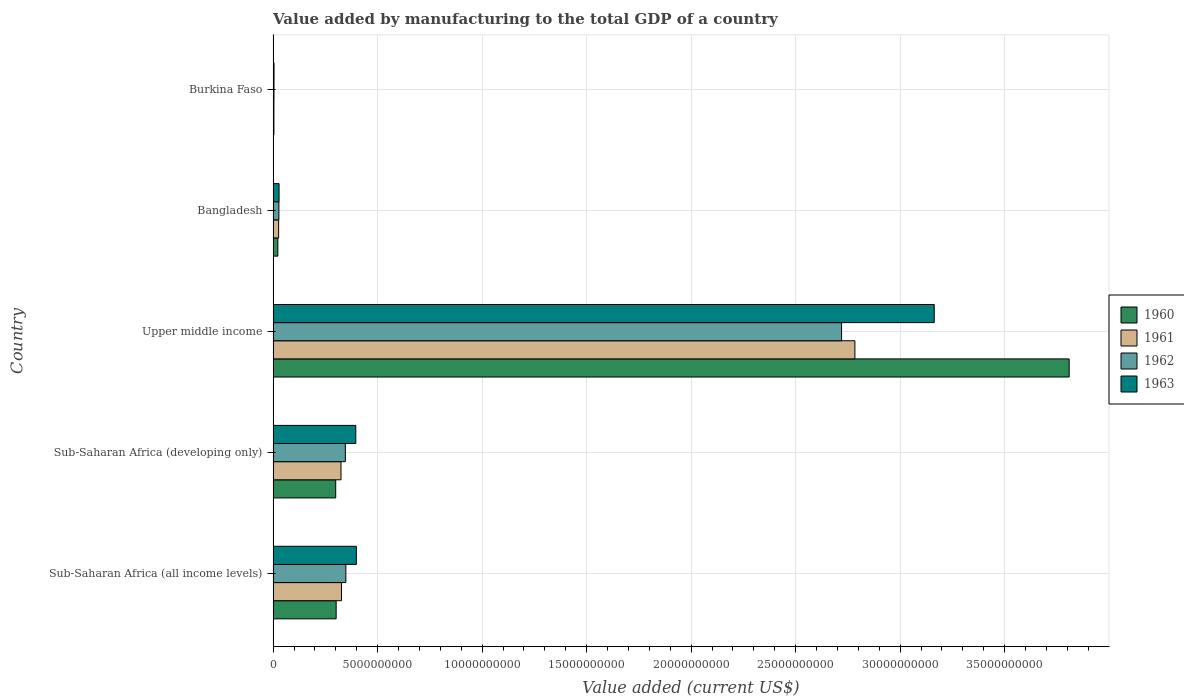How many groups of bars are there?
Give a very brief answer. 5. How many bars are there on the 4th tick from the top?
Offer a very short reply. 4. How many bars are there on the 5th tick from the bottom?
Offer a very short reply. 4. What is the label of the 1st group of bars from the top?
Offer a very short reply. Burkina Faso. In how many cases, is the number of bars for a given country not equal to the number of legend labels?
Make the answer very short. 0. What is the value added by manufacturing to the total GDP in 1960 in Upper middle income?
Your response must be concise. 3.81e+1. Across all countries, what is the maximum value added by manufacturing to the total GDP in 1960?
Your answer should be very brief. 3.81e+1. Across all countries, what is the minimum value added by manufacturing to the total GDP in 1960?
Your answer should be compact. 3.72e+07. In which country was the value added by manufacturing to the total GDP in 1962 maximum?
Your answer should be compact. Upper middle income. In which country was the value added by manufacturing to the total GDP in 1962 minimum?
Make the answer very short. Burkina Faso. What is the total value added by manufacturing to the total GDP in 1961 in the graph?
Ensure brevity in your answer.  3.47e+1. What is the difference between the value added by manufacturing to the total GDP in 1962 in Bangladesh and that in Upper middle income?
Provide a short and direct response. -2.69e+1. What is the difference between the value added by manufacturing to the total GDP in 1963 in Bangladesh and the value added by manufacturing to the total GDP in 1961 in Sub-Saharan Africa (developing only)?
Ensure brevity in your answer.  -2.96e+09. What is the average value added by manufacturing to the total GDP in 1963 per country?
Keep it short and to the point. 7.98e+09. What is the difference between the value added by manufacturing to the total GDP in 1962 and value added by manufacturing to the total GDP in 1960 in Burkina Faso?
Provide a succinct answer. 5.00e+06. What is the ratio of the value added by manufacturing to the total GDP in 1962 in Sub-Saharan Africa (all income levels) to that in Sub-Saharan Africa (developing only)?
Keep it short and to the point. 1.01. Is the value added by manufacturing to the total GDP in 1963 in Burkina Faso less than that in Sub-Saharan Africa (all income levels)?
Ensure brevity in your answer.  Yes. Is the difference between the value added by manufacturing to the total GDP in 1962 in Burkina Faso and Sub-Saharan Africa (developing only) greater than the difference between the value added by manufacturing to the total GDP in 1960 in Burkina Faso and Sub-Saharan Africa (developing only)?
Your response must be concise. No. What is the difference between the highest and the second highest value added by manufacturing to the total GDP in 1961?
Make the answer very short. 2.46e+1. What is the difference between the highest and the lowest value added by manufacturing to the total GDP in 1962?
Provide a succinct answer. 2.72e+1. What does the 4th bar from the bottom in Sub-Saharan Africa (developing only) represents?
Make the answer very short. 1963. What is the difference between two consecutive major ticks on the X-axis?
Ensure brevity in your answer.  5.00e+09. How many legend labels are there?
Your response must be concise. 4. What is the title of the graph?
Your answer should be compact. Value added by manufacturing to the total GDP of a country. What is the label or title of the X-axis?
Keep it short and to the point. Value added (current US$). What is the label or title of the Y-axis?
Ensure brevity in your answer.  Country. What is the Value added (current US$) of 1960 in Sub-Saharan Africa (all income levels)?
Your answer should be compact. 3.02e+09. What is the Value added (current US$) of 1961 in Sub-Saharan Africa (all income levels)?
Your answer should be very brief. 3.27e+09. What is the Value added (current US$) of 1962 in Sub-Saharan Africa (all income levels)?
Your answer should be very brief. 3.48e+09. What is the Value added (current US$) of 1963 in Sub-Saharan Africa (all income levels)?
Offer a very short reply. 3.98e+09. What is the Value added (current US$) in 1960 in Sub-Saharan Africa (developing only)?
Offer a terse response. 2.99e+09. What is the Value added (current US$) of 1961 in Sub-Saharan Africa (developing only)?
Ensure brevity in your answer.  3.25e+09. What is the Value added (current US$) in 1962 in Sub-Saharan Africa (developing only)?
Your answer should be very brief. 3.46e+09. What is the Value added (current US$) in 1963 in Sub-Saharan Africa (developing only)?
Ensure brevity in your answer.  3.95e+09. What is the Value added (current US$) in 1960 in Upper middle income?
Keep it short and to the point. 3.81e+1. What is the Value added (current US$) in 1961 in Upper middle income?
Provide a short and direct response. 2.78e+1. What is the Value added (current US$) in 1962 in Upper middle income?
Your response must be concise. 2.72e+1. What is the Value added (current US$) of 1963 in Upper middle income?
Provide a short and direct response. 3.16e+1. What is the Value added (current US$) in 1960 in Bangladesh?
Your response must be concise. 2.27e+08. What is the Value added (current US$) of 1961 in Bangladesh?
Provide a succinct answer. 2.64e+08. What is the Value added (current US$) of 1962 in Bangladesh?
Your answer should be very brief. 2.77e+08. What is the Value added (current US$) in 1963 in Bangladesh?
Provide a succinct answer. 2.85e+08. What is the Value added (current US$) in 1960 in Burkina Faso?
Give a very brief answer. 3.72e+07. What is the Value added (current US$) of 1961 in Burkina Faso?
Provide a succinct answer. 3.72e+07. What is the Value added (current US$) of 1962 in Burkina Faso?
Make the answer very short. 4.22e+07. What is the Value added (current US$) in 1963 in Burkina Faso?
Offer a very short reply. 4.39e+07. Across all countries, what is the maximum Value added (current US$) in 1960?
Offer a terse response. 3.81e+1. Across all countries, what is the maximum Value added (current US$) of 1961?
Your response must be concise. 2.78e+1. Across all countries, what is the maximum Value added (current US$) in 1962?
Your response must be concise. 2.72e+1. Across all countries, what is the maximum Value added (current US$) in 1963?
Give a very brief answer. 3.16e+1. Across all countries, what is the minimum Value added (current US$) of 1960?
Provide a succinct answer. 3.72e+07. Across all countries, what is the minimum Value added (current US$) of 1961?
Your answer should be compact. 3.72e+07. Across all countries, what is the minimum Value added (current US$) of 1962?
Your answer should be very brief. 4.22e+07. Across all countries, what is the minimum Value added (current US$) of 1963?
Provide a succinct answer. 4.39e+07. What is the total Value added (current US$) in 1960 in the graph?
Your answer should be very brief. 4.44e+1. What is the total Value added (current US$) in 1961 in the graph?
Keep it short and to the point. 3.47e+1. What is the total Value added (current US$) of 1962 in the graph?
Make the answer very short. 3.45e+1. What is the total Value added (current US$) in 1963 in the graph?
Keep it short and to the point. 3.99e+1. What is the difference between the Value added (current US$) of 1960 in Sub-Saharan Africa (all income levels) and that in Sub-Saharan Africa (developing only)?
Offer a terse response. 2.16e+07. What is the difference between the Value added (current US$) in 1961 in Sub-Saharan Africa (all income levels) and that in Sub-Saharan Africa (developing only)?
Keep it short and to the point. 2.34e+07. What is the difference between the Value added (current US$) in 1962 in Sub-Saharan Africa (all income levels) and that in Sub-Saharan Africa (developing only)?
Your answer should be very brief. 2.49e+07. What is the difference between the Value added (current US$) of 1963 in Sub-Saharan Africa (all income levels) and that in Sub-Saharan Africa (developing only)?
Provide a succinct answer. 2.85e+07. What is the difference between the Value added (current US$) in 1960 in Sub-Saharan Africa (all income levels) and that in Upper middle income?
Make the answer very short. -3.51e+1. What is the difference between the Value added (current US$) of 1961 in Sub-Saharan Africa (all income levels) and that in Upper middle income?
Make the answer very short. -2.46e+1. What is the difference between the Value added (current US$) of 1962 in Sub-Saharan Africa (all income levels) and that in Upper middle income?
Provide a short and direct response. -2.37e+1. What is the difference between the Value added (current US$) of 1963 in Sub-Saharan Africa (all income levels) and that in Upper middle income?
Keep it short and to the point. -2.76e+1. What is the difference between the Value added (current US$) in 1960 in Sub-Saharan Africa (all income levels) and that in Bangladesh?
Give a very brief answer. 2.79e+09. What is the difference between the Value added (current US$) in 1961 in Sub-Saharan Africa (all income levels) and that in Bangladesh?
Make the answer very short. 3.01e+09. What is the difference between the Value added (current US$) of 1962 in Sub-Saharan Africa (all income levels) and that in Bangladesh?
Make the answer very short. 3.20e+09. What is the difference between the Value added (current US$) in 1963 in Sub-Saharan Africa (all income levels) and that in Bangladesh?
Make the answer very short. 3.70e+09. What is the difference between the Value added (current US$) of 1960 in Sub-Saharan Africa (all income levels) and that in Burkina Faso?
Make the answer very short. 2.98e+09. What is the difference between the Value added (current US$) of 1961 in Sub-Saharan Africa (all income levels) and that in Burkina Faso?
Your answer should be very brief. 3.23e+09. What is the difference between the Value added (current US$) in 1962 in Sub-Saharan Africa (all income levels) and that in Burkina Faso?
Make the answer very short. 3.44e+09. What is the difference between the Value added (current US$) in 1963 in Sub-Saharan Africa (all income levels) and that in Burkina Faso?
Your response must be concise. 3.94e+09. What is the difference between the Value added (current US$) in 1960 in Sub-Saharan Africa (developing only) and that in Upper middle income?
Give a very brief answer. -3.51e+1. What is the difference between the Value added (current US$) in 1961 in Sub-Saharan Africa (developing only) and that in Upper middle income?
Your response must be concise. -2.46e+1. What is the difference between the Value added (current US$) of 1962 in Sub-Saharan Africa (developing only) and that in Upper middle income?
Keep it short and to the point. -2.37e+1. What is the difference between the Value added (current US$) in 1963 in Sub-Saharan Africa (developing only) and that in Upper middle income?
Provide a succinct answer. -2.77e+1. What is the difference between the Value added (current US$) in 1960 in Sub-Saharan Africa (developing only) and that in Bangladesh?
Offer a very short reply. 2.77e+09. What is the difference between the Value added (current US$) in 1961 in Sub-Saharan Africa (developing only) and that in Bangladesh?
Provide a succinct answer. 2.98e+09. What is the difference between the Value added (current US$) of 1962 in Sub-Saharan Africa (developing only) and that in Bangladesh?
Make the answer very short. 3.18e+09. What is the difference between the Value added (current US$) of 1963 in Sub-Saharan Africa (developing only) and that in Bangladesh?
Give a very brief answer. 3.67e+09. What is the difference between the Value added (current US$) in 1960 in Sub-Saharan Africa (developing only) and that in Burkina Faso?
Ensure brevity in your answer.  2.96e+09. What is the difference between the Value added (current US$) in 1961 in Sub-Saharan Africa (developing only) and that in Burkina Faso?
Offer a terse response. 3.21e+09. What is the difference between the Value added (current US$) of 1962 in Sub-Saharan Africa (developing only) and that in Burkina Faso?
Keep it short and to the point. 3.41e+09. What is the difference between the Value added (current US$) of 1963 in Sub-Saharan Africa (developing only) and that in Burkina Faso?
Your answer should be compact. 3.91e+09. What is the difference between the Value added (current US$) of 1960 in Upper middle income and that in Bangladesh?
Your response must be concise. 3.79e+1. What is the difference between the Value added (current US$) of 1961 in Upper middle income and that in Bangladesh?
Ensure brevity in your answer.  2.76e+1. What is the difference between the Value added (current US$) of 1962 in Upper middle income and that in Bangladesh?
Offer a very short reply. 2.69e+1. What is the difference between the Value added (current US$) of 1963 in Upper middle income and that in Bangladesh?
Your response must be concise. 3.13e+1. What is the difference between the Value added (current US$) in 1960 in Upper middle income and that in Burkina Faso?
Your answer should be very brief. 3.81e+1. What is the difference between the Value added (current US$) of 1961 in Upper middle income and that in Burkina Faso?
Offer a very short reply. 2.78e+1. What is the difference between the Value added (current US$) of 1962 in Upper middle income and that in Burkina Faso?
Your answer should be compact. 2.72e+1. What is the difference between the Value added (current US$) in 1963 in Upper middle income and that in Burkina Faso?
Give a very brief answer. 3.16e+1. What is the difference between the Value added (current US$) of 1960 in Bangladesh and that in Burkina Faso?
Your response must be concise. 1.90e+08. What is the difference between the Value added (current US$) in 1961 in Bangladesh and that in Burkina Faso?
Provide a short and direct response. 2.26e+08. What is the difference between the Value added (current US$) of 1962 in Bangladesh and that in Burkina Faso?
Provide a short and direct response. 2.35e+08. What is the difference between the Value added (current US$) of 1963 in Bangladesh and that in Burkina Faso?
Your answer should be very brief. 2.41e+08. What is the difference between the Value added (current US$) in 1960 in Sub-Saharan Africa (all income levels) and the Value added (current US$) in 1961 in Sub-Saharan Africa (developing only)?
Offer a terse response. -2.32e+08. What is the difference between the Value added (current US$) of 1960 in Sub-Saharan Africa (all income levels) and the Value added (current US$) of 1962 in Sub-Saharan Africa (developing only)?
Provide a succinct answer. -4.40e+08. What is the difference between the Value added (current US$) of 1960 in Sub-Saharan Africa (all income levels) and the Value added (current US$) of 1963 in Sub-Saharan Africa (developing only)?
Provide a short and direct response. -9.39e+08. What is the difference between the Value added (current US$) in 1961 in Sub-Saharan Africa (all income levels) and the Value added (current US$) in 1962 in Sub-Saharan Africa (developing only)?
Give a very brief answer. -1.85e+08. What is the difference between the Value added (current US$) of 1961 in Sub-Saharan Africa (all income levels) and the Value added (current US$) of 1963 in Sub-Saharan Africa (developing only)?
Make the answer very short. -6.84e+08. What is the difference between the Value added (current US$) of 1962 in Sub-Saharan Africa (all income levels) and the Value added (current US$) of 1963 in Sub-Saharan Africa (developing only)?
Provide a short and direct response. -4.74e+08. What is the difference between the Value added (current US$) in 1960 in Sub-Saharan Africa (all income levels) and the Value added (current US$) in 1961 in Upper middle income?
Give a very brief answer. -2.48e+1. What is the difference between the Value added (current US$) of 1960 in Sub-Saharan Africa (all income levels) and the Value added (current US$) of 1962 in Upper middle income?
Give a very brief answer. -2.42e+1. What is the difference between the Value added (current US$) in 1960 in Sub-Saharan Africa (all income levels) and the Value added (current US$) in 1963 in Upper middle income?
Ensure brevity in your answer.  -2.86e+1. What is the difference between the Value added (current US$) in 1961 in Sub-Saharan Africa (all income levels) and the Value added (current US$) in 1962 in Upper middle income?
Offer a terse response. -2.39e+1. What is the difference between the Value added (current US$) of 1961 in Sub-Saharan Africa (all income levels) and the Value added (current US$) of 1963 in Upper middle income?
Offer a very short reply. -2.84e+1. What is the difference between the Value added (current US$) of 1962 in Sub-Saharan Africa (all income levels) and the Value added (current US$) of 1963 in Upper middle income?
Ensure brevity in your answer.  -2.82e+1. What is the difference between the Value added (current US$) in 1960 in Sub-Saharan Africa (all income levels) and the Value added (current US$) in 1961 in Bangladesh?
Provide a succinct answer. 2.75e+09. What is the difference between the Value added (current US$) of 1960 in Sub-Saharan Africa (all income levels) and the Value added (current US$) of 1962 in Bangladesh?
Your response must be concise. 2.74e+09. What is the difference between the Value added (current US$) of 1960 in Sub-Saharan Africa (all income levels) and the Value added (current US$) of 1963 in Bangladesh?
Ensure brevity in your answer.  2.73e+09. What is the difference between the Value added (current US$) of 1961 in Sub-Saharan Africa (all income levels) and the Value added (current US$) of 1962 in Bangladesh?
Give a very brief answer. 2.99e+09. What is the difference between the Value added (current US$) of 1961 in Sub-Saharan Africa (all income levels) and the Value added (current US$) of 1963 in Bangladesh?
Your answer should be very brief. 2.99e+09. What is the difference between the Value added (current US$) of 1962 in Sub-Saharan Africa (all income levels) and the Value added (current US$) of 1963 in Bangladesh?
Make the answer very short. 3.20e+09. What is the difference between the Value added (current US$) of 1960 in Sub-Saharan Africa (all income levels) and the Value added (current US$) of 1961 in Burkina Faso?
Your answer should be compact. 2.98e+09. What is the difference between the Value added (current US$) of 1960 in Sub-Saharan Africa (all income levels) and the Value added (current US$) of 1962 in Burkina Faso?
Ensure brevity in your answer.  2.97e+09. What is the difference between the Value added (current US$) of 1960 in Sub-Saharan Africa (all income levels) and the Value added (current US$) of 1963 in Burkina Faso?
Make the answer very short. 2.97e+09. What is the difference between the Value added (current US$) of 1961 in Sub-Saharan Africa (all income levels) and the Value added (current US$) of 1962 in Burkina Faso?
Ensure brevity in your answer.  3.23e+09. What is the difference between the Value added (current US$) in 1961 in Sub-Saharan Africa (all income levels) and the Value added (current US$) in 1963 in Burkina Faso?
Your response must be concise. 3.23e+09. What is the difference between the Value added (current US$) in 1962 in Sub-Saharan Africa (all income levels) and the Value added (current US$) in 1963 in Burkina Faso?
Your answer should be compact. 3.44e+09. What is the difference between the Value added (current US$) in 1960 in Sub-Saharan Africa (developing only) and the Value added (current US$) in 1961 in Upper middle income?
Keep it short and to the point. -2.48e+1. What is the difference between the Value added (current US$) of 1960 in Sub-Saharan Africa (developing only) and the Value added (current US$) of 1962 in Upper middle income?
Ensure brevity in your answer.  -2.42e+1. What is the difference between the Value added (current US$) of 1960 in Sub-Saharan Africa (developing only) and the Value added (current US$) of 1963 in Upper middle income?
Your answer should be compact. -2.86e+1. What is the difference between the Value added (current US$) in 1961 in Sub-Saharan Africa (developing only) and the Value added (current US$) in 1962 in Upper middle income?
Your response must be concise. -2.40e+1. What is the difference between the Value added (current US$) in 1961 in Sub-Saharan Africa (developing only) and the Value added (current US$) in 1963 in Upper middle income?
Keep it short and to the point. -2.84e+1. What is the difference between the Value added (current US$) of 1962 in Sub-Saharan Africa (developing only) and the Value added (current US$) of 1963 in Upper middle income?
Make the answer very short. -2.82e+1. What is the difference between the Value added (current US$) in 1960 in Sub-Saharan Africa (developing only) and the Value added (current US$) in 1961 in Bangladesh?
Keep it short and to the point. 2.73e+09. What is the difference between the Value added (current US$) in 1960 in Sub-Saharan Africa (developing only) and the Value added (current US$) in 1962 in Bangladesh?
Ensure brevity in your answer.  2.72e+09. What is the difference between the Value added (current US$) of 1960 in Sub-Saharan Africa (developing only) and the Value added (current US$) of 1963 in Bangladesh?
Offer a very short reply. 2.71e+09. What is the difference between the Value added (current US$) of 1961 in Sub-Saharan Africa (developing only) and the Value added (current US$) of 1962 in Bangladesh?
Your response must be concise. 2.97e+09. What is the difference between the Value added (current US$) in 1961 in Sub-Saharan Africa (developing only) and the Value added (current US$) in 1963 in Bangladesh?
Provide a short and direct response. 2.96e+09. What is the difference between the Value added (current US$) of 1962 in Sub-Saharan Africa (developing only) and the Value added (current US$) of 1963 in Bangladesh?
Give a very brief answer. 3.17e+09. What is the difference between the Value added (current US$) in 1960 in Sub-Saharan Africa (developing only) and the Value added (current US$) in 1961 in Burkina Faso?
Ensure brevity in your answer.  2.96e+09. What is the difference between the Value added (current US$) of 1960 in Sub-Saharan Africa (developing only) and the Value added (current US$) of 1962 in Burkina Faso?
Provide a short and direct response. 2.95e+09. What is the difference between the Value added (current US$) of 1960 in Sub-Saharan Africa (developing only) and the Value added (current US$) of 1963 in Burkina Faso?
Your answer should be compact. 2.95e+09. What is the difference between the Value added (current US$) of 1961 in Sub-Saharan Africa (developing only) and the Value added (current US$) of 1962 in Burkina Faso?
Offer a terse response. 3.21e+09. What is the difference between the Value added (current US$) in 1961 in Sub-Saharan Africa (developing only) and the Value added (current US$) in 1963 in Burkina Faso?
Offer a terse response. 3.20e+09. What is the difference between the Value added (current US$) in 1962 in Sub-Saharan Africa (developing only) and the Value added (current US$) in 1963 in Burkina Faso?
Provide a succinct answer. 3.41e+09. What is the difference between the Value added (current US$) of 1960 in Upper middle income and the Value added (current US$) of 1961 in Bangladesh?
Offer a terse response. 3.78e+1. What is the difference between the Value added (current US$) in 1960 in Upper middle income and the Value added (current US$) in 1962 in Bangladesh?
Ensure brevity in your answer.  3.78e+1. What is the difference between the Value added (current US$) in 1960 in Upper middle income and the Value added (current US$) in 1963 in Bangladesh?
Ensure brevity in your answer.  3.78e+1. What is the difference between the Value added (current US$) in 1961 in Upper middle income and the Value added (current US$) in 1962 in Bangladesh?
Your answer should be very brief. 2.76e+1. What is the difference between the Value added (current US$) of 1961 in Upper middle income and the Value added (current US$) of 1963 in Bangladesh?
Ensure brevity in your answer.  2.76e+1. What is the difference between the Value added (current US$) of 1962 in Upper middle income and the Value added (current US$) of 1963 in Bangladesh?
Provide a short and direct response. 2.69e+1. What is the difference between the Value added (current US$) of 1960 in Upper middle income and the Value added (current US$) of 1961 in Burkina Faso?
Offer a terse response. 3.81e+1. What is the difference between the Value added (current US$) of 1960 in Upper middle income and the Value added (current US$) of 1962 in Burkina Faso?
Provide a short and direct response. 3.80e+1. What is the difference between the Value added (current US$) in 1960 in Upper middle income and the Value added (current US$) in 1963 in Burkina Faso?
Provide a succinct answer. 3.80e+1. What is the difference between the Value added (current US$) of 1961 in Upper middle income and the Value added (current US$) of 1962 in Burkina Faso?
Provide a short and direct response. 2.78e+1. What is the difference between the Value added (current US$) in 1961 in Upper middle income and the Value added (current US$) in 1963 in Burkina Faso?
Your answer should be very brief. 2.78e+1. What is the difference between the Value added (current US$) in 1962 in Upper middle income and the Value added (current US$) in 1963 in Burkina Faso?
Your response must be concise. 2.72e+1. What is the difference between the Value added (current US$) of 1960 in Bangladesh and the Value added (current US$) of 1961 in Burkina Faso?
Make the answer very short. 1.90e+08. What is the difference between the Value added (current US$) of 1960 in Bangladesh and the Value added (current US$) of 1962 in Burkina Faso?
Your response must be concise. 1.85e+08. What is the difference between the Value added (current US$) in 1960 in Bangladesh and the Value added (current US$) in 1963 in Burkina Faso?
Make the answer very short. 1.83e+08. What is the difference between the Value added (current US$) of 1961 in Bangladesh and the Value added (current US$) of 1962 in Burkina Faso?
Provide a short and direct response. 2.21e+08. What is the difference between the Value added (current US$) of 1961 in Bangladesh and the Value added (current US$) of 1963 in Burkina Faso?
Your answer should be compact. 2.20e+08. What is the difference between the Value added (current US$) in 1962 in Bangladesh and the Value added (current US$) in 1963 in Burkina Faso?
Your response must be concise. 2.33e+08. What is the average Value added (current US$) of 1960 per country?
Your answer should be very brief. 8.87e+09. What is the average Value added (current US$) of 1961 per country?
Your answer should be very brief. 6.93e+09. What is the average Value added (current US$) in 1962 per country?
Give a very brief answer. 6.89e+09. What is the average Value added (current US$) of 1963 per country?
Provide a succinct answer. 7.98e+09. What is the difference between the Value added (current US$) in 1960 and Value added (current US$) in 1961 in Sub-Saharan Africa (all income levels)?
Offer a very short reply. -2.55e+08. What is the difference between the Value added (current US$) of 1960 and Value added (current US$) of 1962 in Sub-Saharan Africa (all income levels)?
Ensure brevity in your answer.  -4.65e+08. What is the difference between the Value added (current US$) of 1960 and Value added (current US$) of 1963 in Sub-Saharan Africa (all income levels)?
Provide a short and direct response. -9.68e+08. What is the difference between the Value added (current US$) of 1961 and Value added (current US$) of 1962 in Sub-Saharan Africa (all income levels)?
Provide a succinct answer. -2.09e+08. What is the difference between the Value added (current US$) in 1961 and Value added (current US$) in 1963 in Sub-Saharan Africa (all income levels)?
Your answer should be very brief. -7.12e+08. What is the difference between the Value added (current US$) in 1962 and Value added (current US$) in 1963 in Sub-Saharan Africa (all income levels)?
Provide a short and direct response. -5.03e+08. What is the difference between the Value added (current US$) in 1960 and Value added (current US$) in 1961 in Sub-Saharan Africa (developing only)?
Your response must be concise. -2.54e+08. What is the difference between the Value added (current US$) of 1960 and Value added (current US$) of 1962 in Sub-Saharan Africa (developing only)?
Ensure brevity in your answer.  -4.61e+08. What is the difference between the Value added (current US$) of 1960 and Value added (current US$) of 1963 in Sub-Saharan Africa (developing only)?
Ensure brevity in your answer.  -9.61e+08. What is the difference between the Value added (current US$) in 1961 and Value added (current US$) in 1962 in Sub-Saharan Africa (developing only)?
Your answer should be very brief. -2.08e+08. What is the difference between the Value added (current US$) in 1961 and Value added (current US$) in 1963 in Sub-Saharan Africa (developing only)?
Your answer should be very brief. -7.07e+08. What is the difference between the Value added (current US$) of 1962 and Value added (current US$) of 1963 in Sub-Saharan Africa (developing only)?
Offer a very short reply. -4.99e+08. What is the difference between the Value added (current US$) of 1960 and Value added (current US$) of 1961 in Upper middle income?
Give a very brief answer. 1.03e+1. What is the difference between the Value added (current US$) of 1960 and Value added (current US$) of 1962 in Upper middle income?
Provide a succinct answer. 1.09e+1. What is the difference between the Value added (current US$) in 1960 and Value added (current US$) in 1963 in Upper middle income?
Keep it short and to the point. 6.46e+09. What is the difference between the Value added (current US$) in 1961 and Value added (current US$) in 1962 in Upper middle income?
Ensure brevity in your answer.  6.38e+08. What is the difference between the Value added (current US$) of 1961 and Value added (current US$) of 1963 in Upper middle income?
Keep it short and to the point. -3.80e+09. What is the difference between the Value added (current US$) in 1962 and Value added (current US$) in 1963 in Upper middle income?
Offer a terse response. -4.43e+09. What is the difference between the Value added (current US$) in 1960 and Value added (current US$) in 1961 in Bangladesh?
Offer a terse response. -3.66e+07. What is the difference between the Value added (current US$) of 1960 and Value added (current US$) of 1962 in Bangladesh?
Offer a very short reply. -4.99e+07. What is the difference between the Value added (current US$) of 1960 and Value added (current US$) of 1963 in Bangladesh?
Your answer should be compact. -5.81e+07. What is the difference between the Value added (current US$) of 1961 and Value added (current US$) of 1962 in Bangladesh?
Ensure brevity in your answer.  -1.33e+07. What is the difference between the Value added (current US$) in 1961 and Value added (current US$) in 1963 in Bangladesh?
Provide a succinct answer. -2.15e+07. What is the difference between the Value added (current US$) in 1962 and Value added (current US$) in 1963 in Bangladesh?
Your response must be concise. -8.22e+06. What is the difference between the Value added (current US$) in 1960 and Value added (current US$) in 1961 in Burkina Faso?
Provide a short and direct response. 9866.11. What is the difference between the Value added (current US$) of 1960 and Value added (current US$) of 1962 in Burkina Faso?
Offer a very short reply. -5.00e+06. What is the difference between the Value added (current US$) of 1960 and Value added (current US$) of 1963 in Burkina Faso?
Offer a very short reply. -6.65e+06. What is the difference between the Value added (current US$) in 1961 and Value added (current US$) in 1962 in Burkina Faso?
Give a very brief answer. -5.01e+06. What is the difference between the Value added (current US$) of 1961 and Value added (current US$) of 1963 in Burkina Faso?
Provide a short and direct response. -6.66e+06. What is the difference between the Value added (current US$) in 1962 and Value added (current US$) in 1963 in Burkina Faso?
Your answer should be very brief. -1.65e+06. What is the ratio of the Value added (current US$) in 1961 in Sub-Saharan Africa (all income levels) to that in Sub-Saharan Africa (developing only)?
Ensure brevity in your answer.  1.01. What is the ratio of the Value added (current US$) in 1962 in Sub-Saharan Africa (all income levels) to that in Sub-Saharan Africa (developing only)?
Your answer should be very brief. 1.01. What is the ratio of the Value added (current US$) in 1960 in Sub-Saharan Africa (all income levels) to that in Upper middle income?
Offer a terse response. 0.08. What is the ratio of the Value added (current US$) in 1961 in Sub-Saharan Africa (all income levels) to that in Upper middle income?
Your answer should be very brief. 0.12. What is the ratio of the Value added (current US$) of 1962 in Sub-Saharan Africa (all income levels) to that in Upper middle income?
Your response must be concise. 0.13. What is the ratio of the Value added (current US$) of 1963 in Sub-Saharan Africa (all income levels) to that in Upper middle income?
Your answer should be compact. 0.13. What is the ratio of the Value added (current US$) of 1960 in Sub-Saharan Africa (all income levels) to that in Bangladesh?
Your answer should be compact. 13.29. What is the ratio of the Value added (current US$) in 1961 in Sub-Saharan Africa (all income levels) to that in Bangladesh?
Your answer should be compact. 12.41. What is the ratio of the Value added (current US$) in 1962 in Sub-Saharan Africa (all income levels) to that in Bangladesh?
Offer a very short reply. 12.57. What is the ratio of the Value added (current US$) of 1963 in Sub-Saharan Africa (all income levels) to that in Bangladesh?
Give a very brief answer. 13.97. What is the ratio of the Value added (current US$) of 1960 in Sub-Saharan Africa (all income levels) to that in Burkina Faso?
Provide a succinct answer. 81.01. What is the ratio of the Value added (current US$) in 1961 in Sub-Saharan Africa (all income levels) to that in Burkina Faso?
Your response must be concise. 87.89. What is the ratio of the Value added (current US$) of 1962 in Sub-Saharan Africa (all income levels) to that in Burkina Faso?
Your response must be concise. 82.42. What is the ratio of the Value added (current US$) of 1963 in Sub-Saharan Africa (all income levels) to that in Burkina Faso?
Give a very brief answer. 90.77. What is the ratio of the Value added (current US$) in 1960 in Sub-Saharan Africa (developing only) to that in Upper middle income?
Keep it short and to the point. 0.08. What is the ratio of the Value added (current US$) in 1961 in Sub-Saharan Africa (developing only) to that in Upper middle income?
Give a very brief answer. 0.12. What is the ratio of the Value added (current US$) of 1962 in Sub-Saharan Africa (developing only) to that in Upper middle income?
Your answer should be very brief. 0.13. What is the ratio of the Value added (current US$) in 1960 in Sub-Saharan Africa (developing only) to that in Bangladesh?
Ensure brevity in your answer.  13.19. What is the ratio of the Value added (current US$) of 1961 in Sub-Saharan Africa (developing only) to that in Bangladesh?
Your answer should be very brief. 12.32. What is the ratio of the Value added (current US$) of 1962 in Sub-Saharan Africa (developing only) to that in Bangladesh?
Your answer should be very brief. 12.48. What is the ratio of the Value added (current US$) in 1963 in Sub-Saharan Africa (developing only) to that in Bangladesh?
Your answer should be very brief. 13.87. What is the ratio of the Value added (current US$) in 1960 in Sub-Saharan Africa (developing only) to that in Burkina Faso?
Give a very brief answer. 80.43. What is the ratio of the Value added (current US$) in 1961 in Sub-Saharan Africa (developing only) to that in Burkina Faso?
Your answer should be compact. 87.26. What is the ratio of the Value added (current US$) of 1962 in Sub-Saharan Africa (developing only) to that in Burkina Faso?
Give a very brief answer. 81.83. What is the ratio of the Value added (current US$) in 1963 in Sub-Saharan Africa (developing only) to that in Burkina Faso?
Provide a short and direct response. 90.13. What is the ratio of the Value added (current US$) of 1960 in Upper middle income to that in Bangladesh?
Offer a very short reply. 167.8. What is the ratio of the Value added (current US$) in 1961 in Upper middle income to that in Bangladesh?
Ensure brevity in your answer.  105.62. What is the ratio of the Value added (current US$) of 1962 in Upper middle income to that in Bangladesh?
Your response must be concise. 98.24. What is the ratio of the Value added (current US$) of 1963 in Upper middle income to that in Bangladesh?
Your response must be concise. 110.96. What is the ratio of the Value added (current US$) in 1960 in Upper middle income to that in Burkina Faso?
Make the answer very short. 1023.17. What is the ratio of the Value added (current US$) in 1961 in Upper middle income to that in Burkina Faso?
Your response must be concise. 747.95. What is the ratio of the Value added (current US$) of 1962 in Upper middle income to that in Burkina Faso?
Ensure brevity in your answer.  644.09. What is the ratio of the Value added (current US$) of 1963 in Upper middle income to that in Burkina Faso?
Ensure brevity in your answer.  720.87. What is the ratio of the Value added (current US$) in 1960 in Bangladesh to that in Burkina Faso?
Keep it short and to the point. 6.1. What is the ratio of the Value added (current US$) of 1961 in Bangladesh to that in Burkina Faso?
Make the answer very short. 7.08. What is the ratio of the Value added (current US$) in 1962 in Bangladesh to that in Burkina Faso?
Make the answer very short. 6.56. What is the ratio of the Value added (current US$) in 1963 in Bangladesh to that in Burkina Faso?
Offer a terse response. 6.5. What is the difference between the highest and the second highest Value added (current US$) of 1960?
Keep it short and to the point. 3.51e+1. What is the difference between the highest and the second highest Value added (current US$) of 1961?
Offer a terse response. 2.46e+1. What is the difference between the highest and the second highest Value added (current US$) in 1962?
Provide a short and direct response. 2.37e+1. What is the difference between the highest and the second highest Value added (current US$) in 1963?
Keep it short and to the point. 2.76e+1. What is the difference between the highest and the lowest Value added (current US$) in 1960?
Make the answer very short. 3.81e+1. What is the difference between the highest and the lowest Value added (current US$) of 1961?
Offer a terse response. 2.78e+1. What is the difference between the highest and the lowest Value added (current US$) in 1962?
Your answer should be compact. 2.72e+1. What is the difference between the highest and the lowest Value added (current US$) of 1963?
Keep it short and to the point. 3.16e+1. 